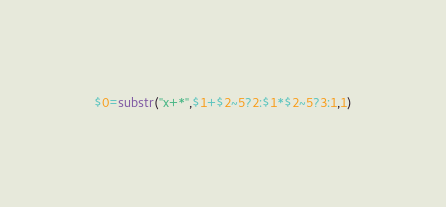<code> <loc_0><loc_0><loc_500><loc_500><_Awk_>$0=substr("x+*",$1+$2~5?2:$1*$2~5?3:1,1)</code> 